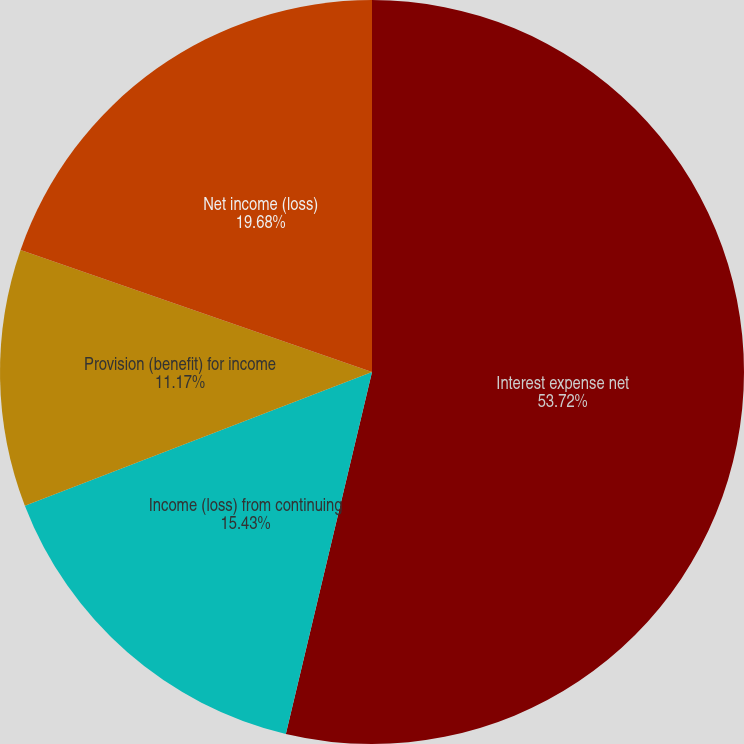Convert chart. <chart><loc_0><loc_0><loc_500><loc_500><pie_chart><fcel>Interest expense net<fcel>Income (loss) from continuing<fcel>Provision (benefit) for income<fcel>Net income (loss)<nl><fcel>53.72%<fcel>15.43%<fcel>11.17%<fcel>19.68%<nl></chart> 